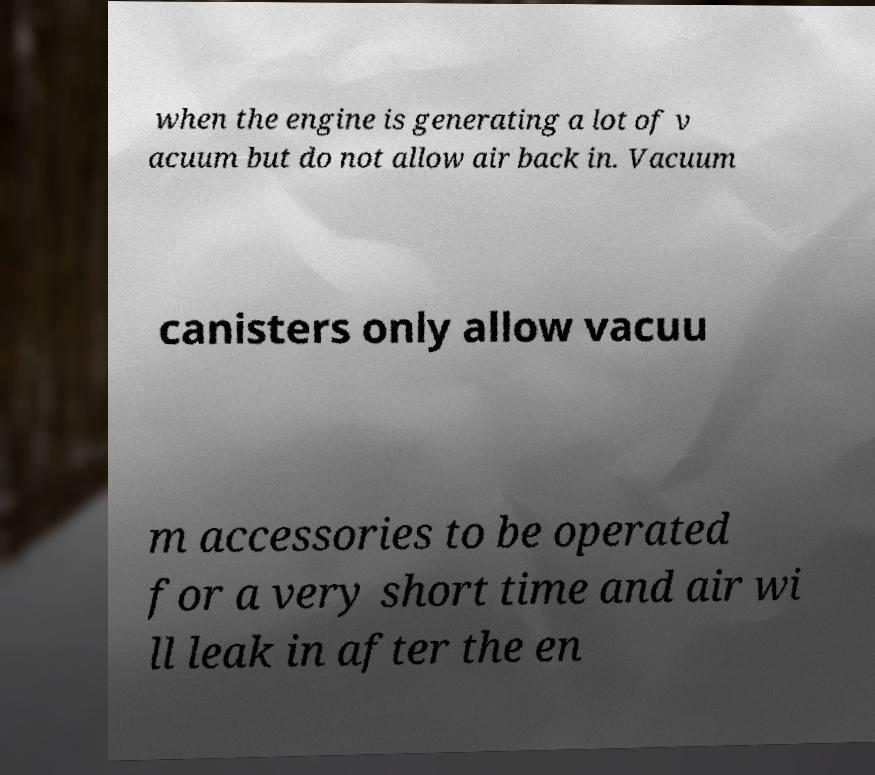Could you assist in decoding the text presented in this image and type it out clearly? when the engine is generating a lot of v acuum but do not allow air back in. Vacuum canisters only allow vacuu m accessories to be operated for a very short time and air wi ll leak in after the en 